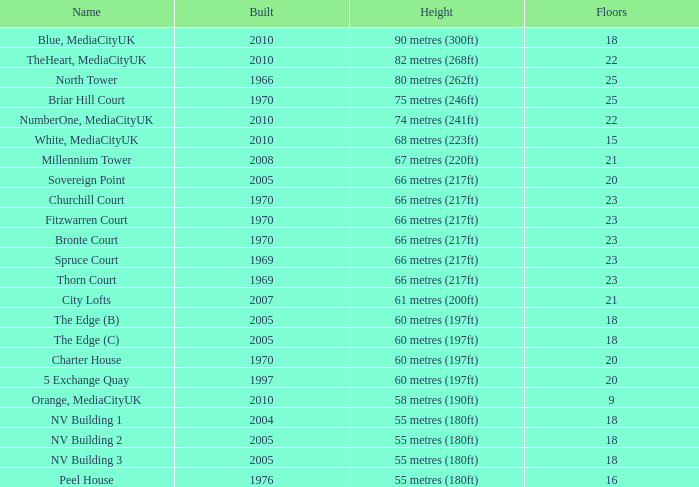What is the total count of constructed buildings with less than 22 floors, a rank lower than 8, and named white mediacityuk? 1.0. 